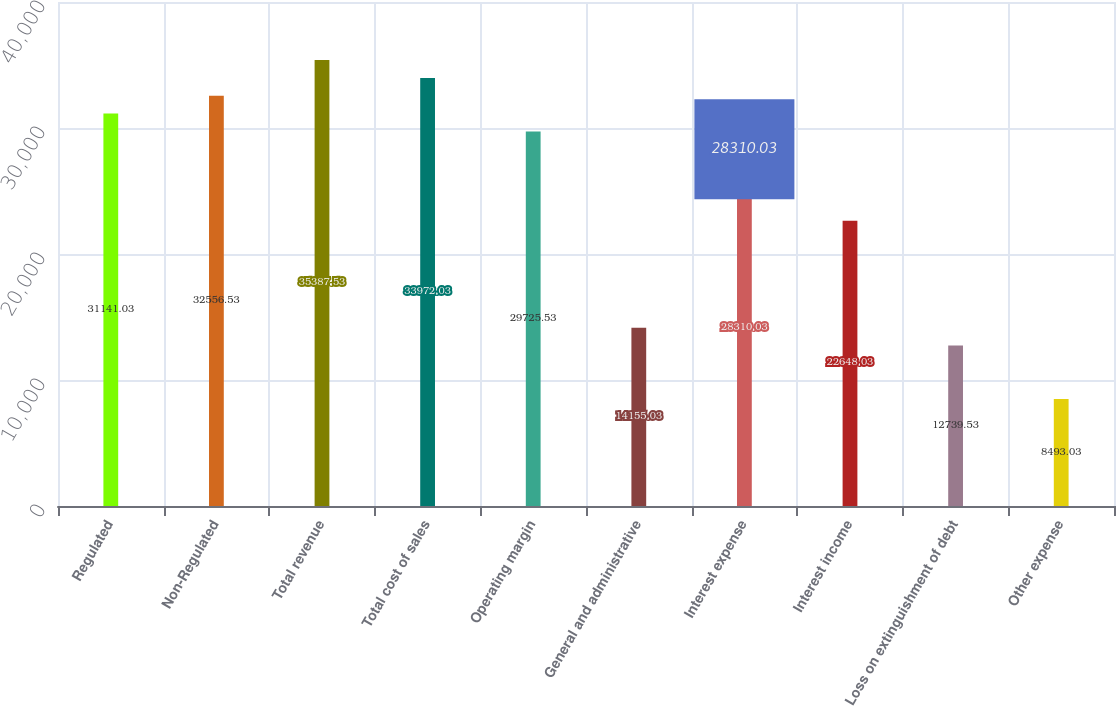Convert chart. <chart><loc_0><loc_0><loc_500><loc_500><bar_chart><fcel>Regulated<fcel>Non-Regulated<fcel>Total revenue<fcel>Total cost of sales<fcel>Operating margin<fcel>General and administrative<fcel>Interest expense<fcel>Interest income<fcel>Loss on extinguishment of debt<fcel>Other expense<nl><fcel>31141<fcel>32556.5<fcel>35387.5<fcel>33972<fcel>29725.5<fcel>14155<fcel>28310<fcel>22648<fcel>12739.5<fcel>8493.03<nl></chart> 